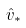Convert formula to latex. <formula><loc_0><loc_0><loc_500><loc_500>\hat { v } _ { * }</formula> 